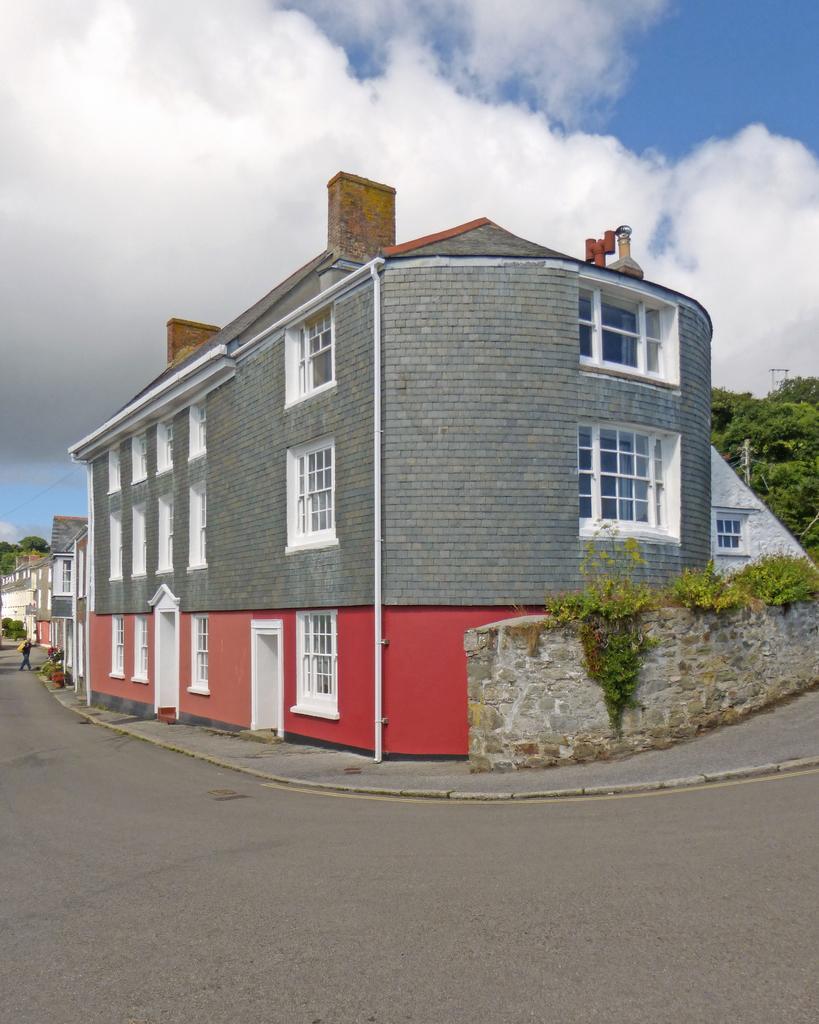In one or two sentences, can you explain what this image depicts? In this image there are buildings and trees and there is a wall. In the background there is a person walking and the sky is cloudy. 